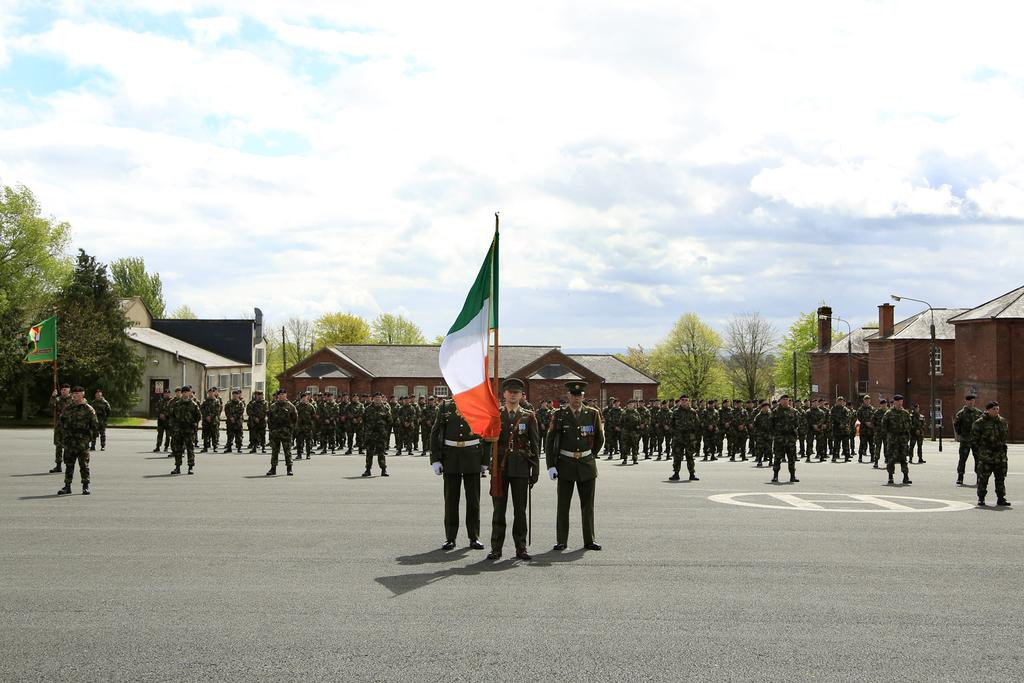What are the persons in the image wearing? The persons in the image are wearing uniforms. Where are the persons located in the image? The persons are standing on the ground. How many flags can be seen in the image? There are two flags in the image. What can be seen in the background of the image? There are buildings, trees, and the sky visible in the background of the image. Can you tell me how many times the tramp jumps in the image? There is no tramp present in the image, so it is not possible to determine how many times it jumps. Is the grandmother visible in the image? There is no mention of a grandmother in the provided facts, and therefore it cannot be determined if she is present in the image. 